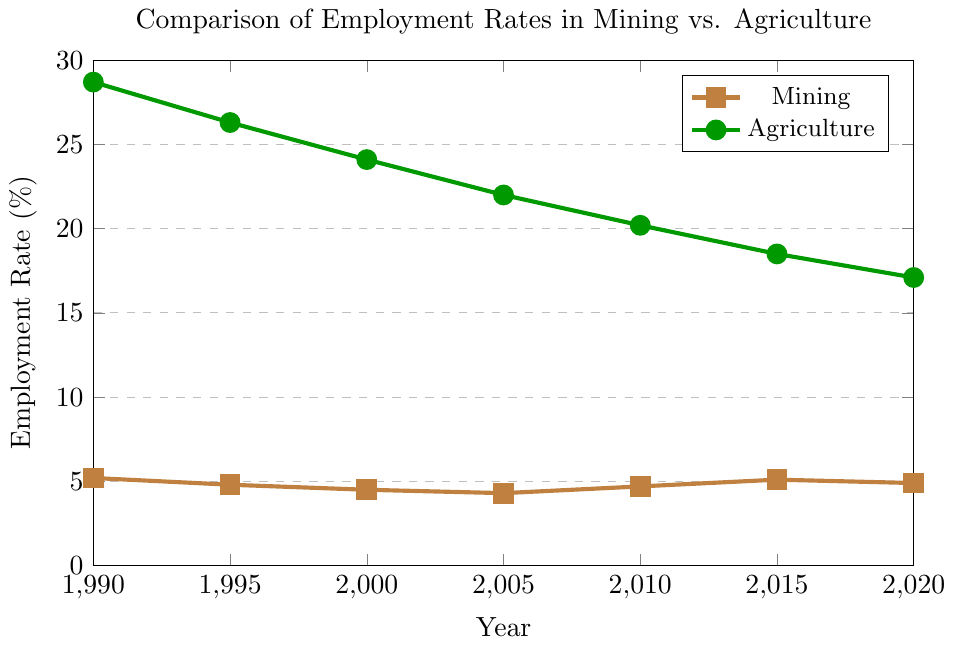What is the employment rate in the agriculture sector in 2000? Look at the data point on the line representing the agriculture sector for the year 2000. The value is 24.1%
Answer: 24.1% How does the mining employment rate in 1990 compare to 2020? Check the values of the mining employment rate in 1990 and 2020 from the plot. In 1990, it is 5.2% and in 2020, it is 4.9%. The employment rate in 1990 is higher than in 2020
Answer: The rate in 1990 is higher What is the overall trend in the agricultural employment rate from 1990 to 2020? Observe the line representing agriculture from 1990 to 2020. The values go from 28.7% in 1990, steadily decreasing to 17.1% in 2020, indicating a downward trend
Answer: Downward trend What is the combined employment rate for both sectors in 2010? Find the employment rates for both sectors in 2010. Agriculture is 20.2% and mining is 4.7%. Sum these two values (20.2 + 4.7) = 24.9%
Answer: 24.9% In which year does the mining sector see its lowest employment rate, and what is the rate? Look for the lowest point on the line representing mining employment. The lowest rate is in 2005 at 4.3%
Answer: 2005, 4.3% What is the average employment rate in the agriculture sector over the 30-year period? Calculate the average by summing all the agriculture employment rates and dividing by the number of data points (28.7 + 26.3 + 24.1 + 22 + 20.2 + 18.5 + 17.1) / 7 = 156.9 / 7
Answer: 22.4% How many percentage points difference is there between agricultural and mining employment rates in 1995? Subtract the mining employment rate from the agriculture employment rate in 1995 (26.3 - 4.8) = 21.5 percentage points
Answer: 21.5 How does the employment rate trend in the mining sector between 2005 and 2015? Look at the values from 2005 to 2015 for the mining sector: 4.3% in 2005, 4.7% in 2010, and 5.1% in 2015. The rate increases overall
Answer: Increasing Which sector shows more stability in employment rates over the 30-year period? Compare the changes in rates for both sectors. The agriculture sector shows larger fluctuations, while the mining sector shows relatively smaller changes, indicating more stability
Answer: Mining sector What is the difference in the employment rate of the agriculture sector between 1990 and 2020? Subtract the 2020 agriculture employment rate from the 1990 rate (28.7 - 17.1) = 11.6
Answer: 11.6 